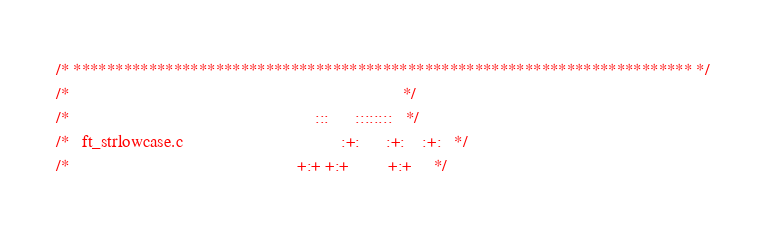<code> <loc_0><loc_0><loc_500><loc_500><_C_>/* ************************************************************************** */
/*                                                                            */
/*                                                        :::      ::::::::   */
/*   ft_strlowcase.c                                    :+:      :+:    :+:   */
/*                                                    +:+ +:+         +:+     */</code> 